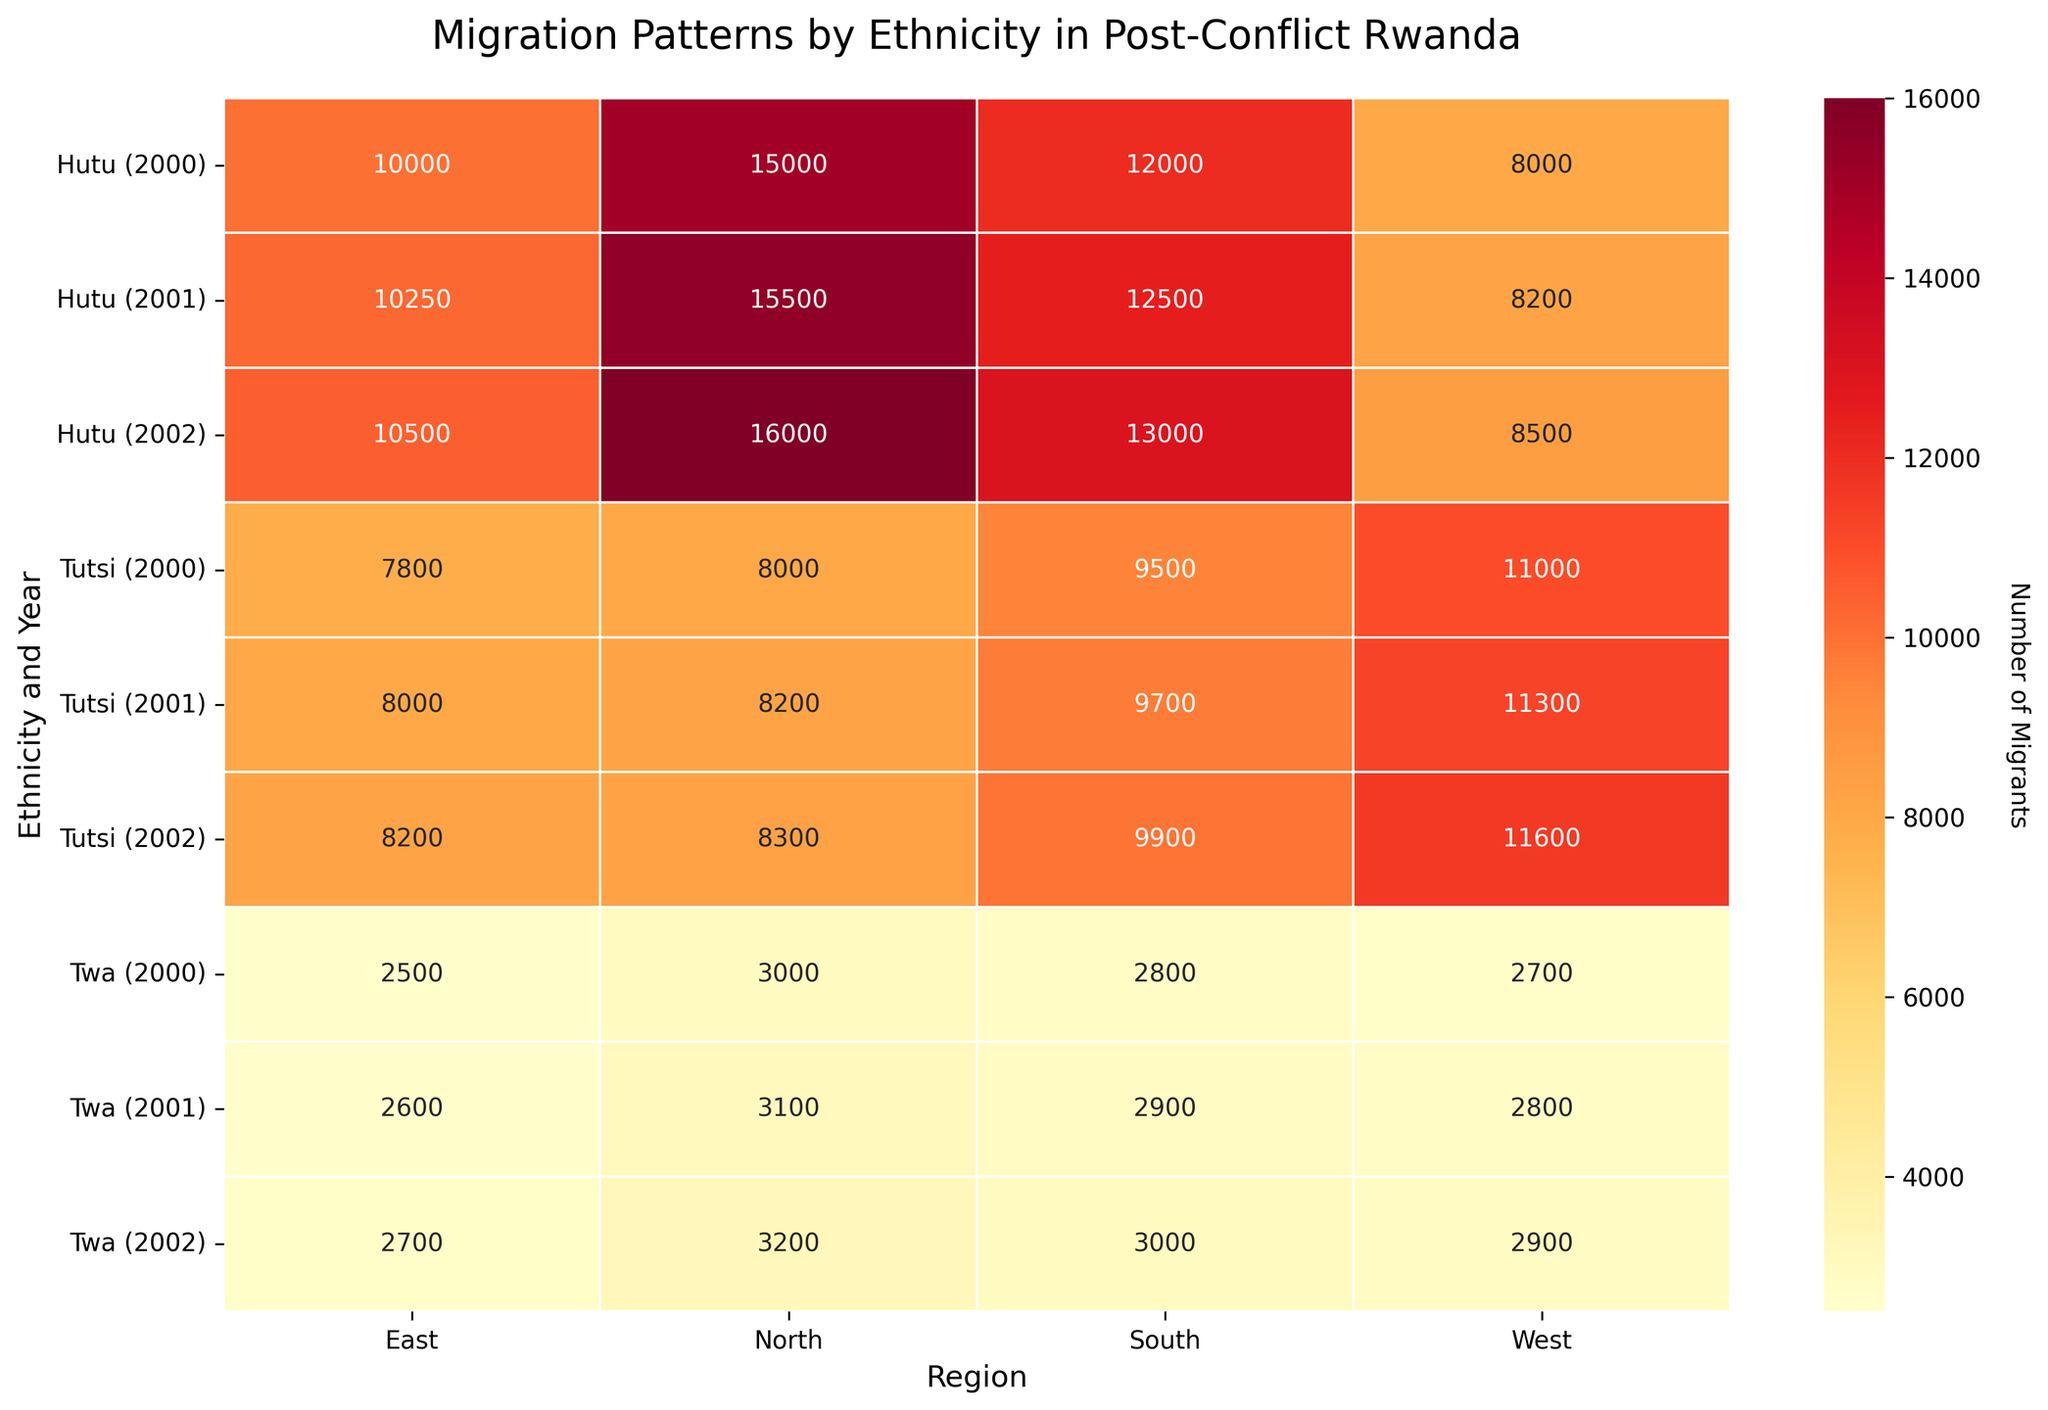What is the color representing the highest number of migrants? The heatmap uses the `YlOrRd` color scheme, where darker shades of red indicate higher values. The darkest red color represents the highest number of migrants.
Answer: Darkest red What was the migration pattern for the Hutu ethnicity in the North region from 2000 to 2002? The numbers for Hutu in the North region across the years 2000, 2001, and 2002 are represented in different shades of color. The annotations show the values as 15000, 15500, and 16000. This indicates an increasing trend in the number of migrants.
Answer: Increasing trend: 15000, 15500, 16000 Which ethnicity and year had the lowest number of migrants in the East region? By looking at the annotations for the East region column across all ethnicities and years, the lowest value is found in the Twa (2000) cell, which shows 2500.
Answer: Twa in 2000 How did the number of Tutsi migrants change in the West region from 2000 to 2002? Checking the values for Tutsi in the West region over the years 2000, 2001, and 2002, the numbers are 11000, 11300, and 11600 respectively. This shows an increase each year.
Answer: Increased: 11000, 11300, 11600 What is the median number of migrants for the South region across all years and ethnicities? Collect the numbers for the South region: 12000 (Hutu 2000), 12500 (Hutu 2001), 13000 (Hutu 2002), 9500 (Tutsi 2000), 9700 (Tutsi 2001), 9900 (Tutsi 2002), 2800 (Twa 2000), 2900 (Twa 2001), and 3000 (Twa 2002). Sorting these values gives 2800, 2900, 3000, 9500, 9700, 9900, 12000, 12500, 13000. The middle value is 9700.
Answer: 9700 Between Hutu and Tutsi in the year 2002, which ethnicity had more migrants in the East region? By checking the values for the East region in 2002 for both Hutu and Tutsi, Hutu has 10500 migrants and Tutsi has 8200. Therefore, Hutu had more migrants.
Answer: Hutu In which year did the Twa ethnicity see the highest number of migrants in the North region? By comparing the values for Twa in the North region across all years, we see the following values: 3000 (2000), 3100 (2001), and 3200 (2002). The highest number is 3200 in 2002.
Answer: 2002 